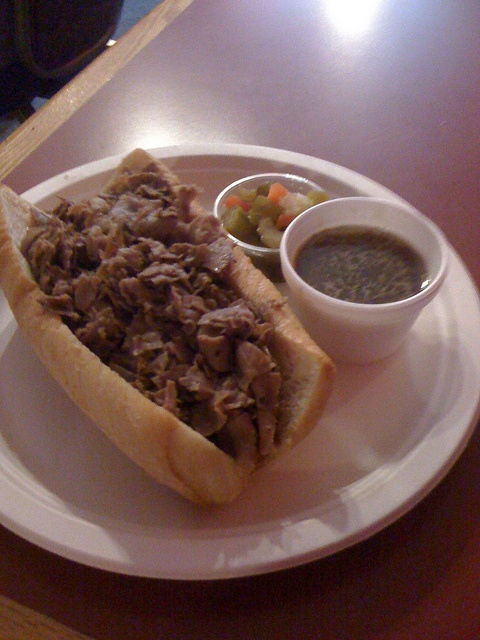Describe the objects in this image and their specific colors. I can see dining table in darkgray, black, gray, maroon, and brown tones, sandwich in black, maroon, gray, and brown tones, cup in black, darkgray, gray, brown, and maroon tones, bowl in black, darkgray, gray, brown, and maroon tones, and chair in black, navy, and purple tones in this image. 